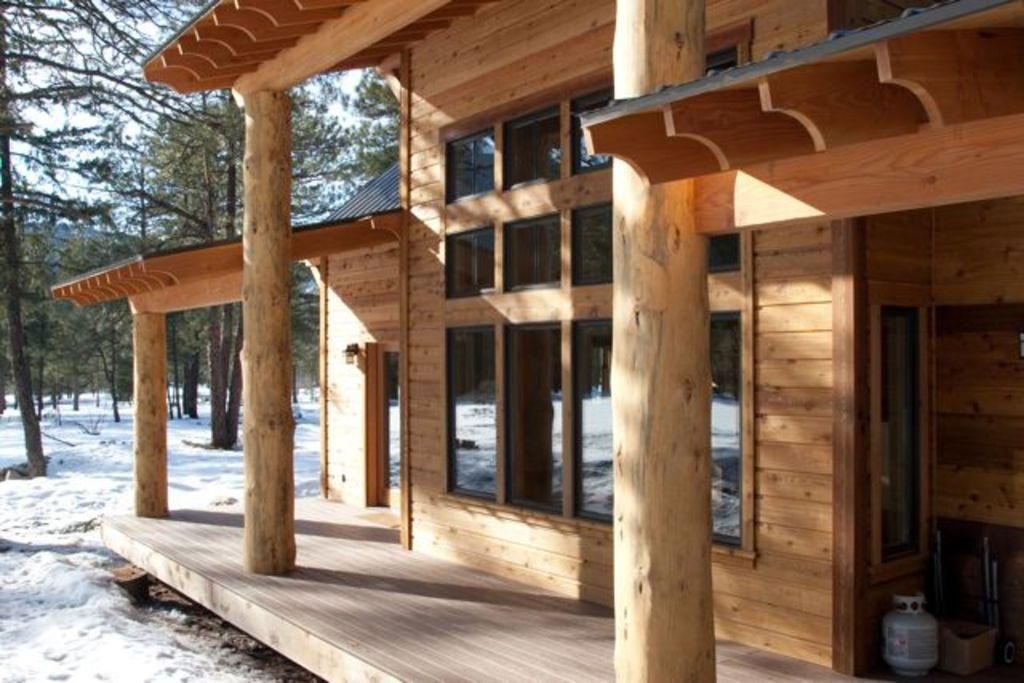What type of structure is visible in the image? There is a house in the image. What material is used for the windows and doors of the house? Window glasses and glass doors are visible in the image. What can be seen on the floor inside the house? There are objects on the floor in the image. What is visible in the background of the image? Trees, snow on the ground, and the sky are visible in the background of the image. What type of flesh can be seen hanging from the trees in the image? There is no flesh visible in the image; the trees are covered in snow. What type of straw is used to decorate the house in the image? There is no straw present in the image; the house is made of traditional building materials. 